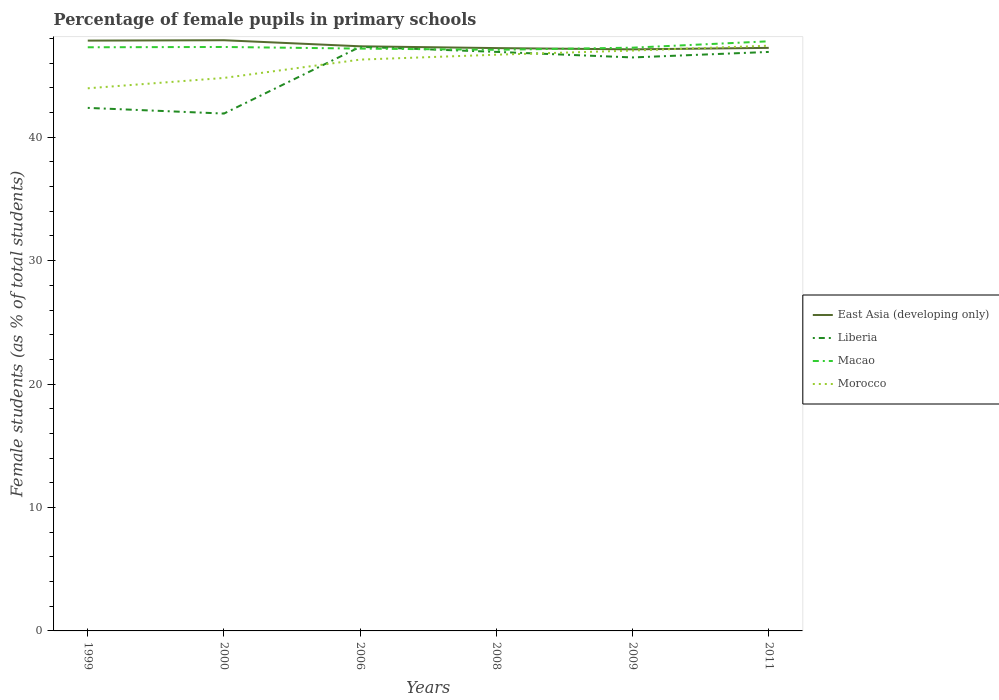Does the line corresponding to East Asia (developing only) intersect with the line corresponding to Morocco?
Your answer should be compact. Yes. Across all years, what is the maximum percentage of female pupils in primary schools in Morocco?
Your response must be concise. 43.97. What is the total percentage of female pupils in primary schools in Liberia in the graph?
Give a very brief answer. -5. What is the difference between the highest and the second highest percentage of female pupils in primary schools in Liberia?
Make the answer very short. 5.41. Is the percentage of female pupils in primary schools in Morocco strictly greater than the percentage of female pupils in primary schools in East Asia (developing only) over the years?
Give a very brief answer. No. How many years are there in the graph?
Provide a short and direct response. 6. How many legend labels are there?
Ensure brevity in your answer.  4. How are the legend labels stacked?
Give a very brief answer. Vertical. What is the title of the graph?
Provide a short and direct response. Percentage of female pupils in primary schools. What is the label or title of the Y-axis?
Provide a short and direct response. Female students (as % of total students). What is the Female students (as % of total students) of East Asia (developing only) in 1999?
Give a very brief answer. 47.83. What is the Female students (as % of total students) of Liberia in 1999?
Provide a short and direct response. 42.38. What is the Female students (as % of total students) in Macao in 1999?
Your response must be concise. 47.29. What is the Female students (as % of total students) of Morocco in 1999?
Provide a short and direct response. 43.97. What is the Female students (as % of total students) in East Asia (developing only) in 2000?
Ensure brevity in your answer.  47.86. What is the Female students (as % of total students) in Liberia in 2000?
Ensure brevity in your answer.  41.92. What is the Female students (as % of total students) of Macao in 2000?
Provide a succinct answer. 47.31. What is the Female students (as % of total students) of Morocco in 2000?
Your answer should be very brief. 44.81. What is the Female students (as % of total students) of East Asia (developing only) in 2006?
Your answer should be compact. 47.37. What is the Female students (as % of total students) in Liberia in 2006?
Provide a short and direct response. 47.33. What is the Female students (as % of total students) in Macao in 2006?
Your response must be concise. 47.18. What is the Female students (as % of total students) in Morocco in 2006?
Your answer should be very brief. 46.29. What is the Female students (as % of total students) of East Asia (developing only) in 2008?
Make the answer very short. 47.22. What is the Female students (as % of total students) of Liberia in 2008?
Offer a very short reply. 46.92. What is the Female students (as % of total students) of Macao in 2008?
Offer a very short reply. 47.09. What is the Female students (as % of total students) in Morocco in 2008?
Provide a succinct answer. 46.69. What is the Female students (as % of total students) in East Asia (developing only) in 2009?
Offer a terse response. 47.12. What is the Female students (as % of total students) of Liberia in 2009?
Make the answer very short. 46.47. What is the Female students (as % of total students) of Macao in 2009?
Give a very brief answer. 47.26. What is the Female students (as % of total students) in Morocco in 2009?
Your answer should be very brief. 47.03. What is the Female students (as % of total students) in East Asia (developing only) in 2011?
Make the answer very short. 47.24. What is the Female students (as % of total students) of Liberia in 2011?
Give a very brief answer. 46.91. What is the Female students (as % of total students) in Macao in 2011?
Keep it short and to the point. 47.77. What is the Female students (as % of total students) of Morocco in 2011?
Your response must be concise. 47.42. Across all years, what is the maximum Female students (as % of total students) in East Asia (developing only)?
Ensure brevity in your answer.  47.86. Across all years, what is the maximum Female students (as % of total students) in Liberia?
Offer a very short reply. 47.33. Across all years, what is the maximum Female students (as % of total students) of Macao?
Keep it short and to the point. 47.77. Across all years, what is the maximum Female students (as % of total students) in Morocco?
Provide a short and direct response. 47.42. Across all years, what is the minimum Female students (as % of total students) in East Asia (developing only)?
Ensure brevity in your answer.  47.12. Across all years, what is the minimum Female students (as % of total students) of Liberia?
Keep it short and to the point. 41.92. Across all years, what is the minimum Female students (as % of total students) in Macao?
Offer a terse response. 47.09. Across all years, what is the minimum Female students (as % of total students) of Morocco?
Give a very brief answer. 43.97. What is the total Female students (as % of total students) of East Asia (developing only) in the graph?
Provide a short and direct response. 284.65. What is the total Female students (as % of total students) of Liberia in the graph?
Make the answer very short. 271.92. What is the total Female students (as % of total students) of Macao in the graph?
Offer a very short reply. 283.91. What is the total Female students (as % of total students) of Morocco in the graph?
Your answer should be compact. 276.2. What is the difference between the Female students (as % of total students) of East Asia (developing only) in 1999 and that in 2000?
Make the answer very short. -0.03. What is the difference between the Female students (as % of total students) of Liberia in 1999 and that in 2000?
Make the answer very short. 0.46. What is the difference between the Female students (as % of total students) of Macao in 1999 and that in 2000?
Offer a terse response. -0.02. What is the difference between the Female students (as % of total students) in Morocco in 1999 and that in 2000?
Keep it short and to the point. -0.84. What is the difference between the Female students (as % of total students) of East Asia (developing only) in 1999 and that in 2006?
Make the answer very short. 0.46. What is the difference between the Female students (as % of total students) in Liberia in 1999 and that in 2006?
Give a very brief answer. -4.95. What is the difference between the Female students (as % of total students) of Macao in 1999 and that in 2006?
Provide a short and direct response. 0.11. What is the difference between the Female students (as % of total students) in Morocco in 1999 and that in 2006?
Ensure brevity in your answer.  -2.32. What is the difference between the Female students (as % of total students) of East Asia (developing only) in 1999 and that in 2008?
Make the answer very short. 0.61. What is the difference between the Female students (as % of total students) of Liberia in 1999 and that in 2008?
Give a very brief answer. -4.54. What is the difference between the Female students (as % of total students) of Macao in 1999 and that in 2008?
Offer a very short reply. 0.2. What is the difference between the Female students (as % of total students) of Morocco in 1999 and that in 2008?
Provide a succinct answer. -2.72. What is the difference between the Female students (as % of total students) of East Asia (developing only) in 1999 and that in 2009?
Give a very brief answer. 0.71. What is the difference between the Female students (as % of total students) in Liberia in 1999 and that in 2009?
Keep it short and to the point. -4.09. What is the difference between the Female students (as % of total students) of Macao in 1999 and that in 2009?
Make the answer very short. 0.03. What is the difference between the Female students (as % of total students) of Morocco in 1999 and that in 2009?
Keep it short and to the point. -3.06. What is the difference between the Female students (as % of total students) in East Asia (developing only) in 1999 and that in 2011?
Your answer should be compact. 0.59. What is the difference between the Female students (as % of total students) in Liberia in 1999 and that in 2011?
Your response must be concise. -4.53. What is the difference between the Female students (as % of total students) in Macao in 1999 and that in 2011?
Your answer should be very brief. -0.48. What is the difference between the Female students (as % of total students) of Morocco in 1999 and that in 2011?
Your response must be concise. -3.45. What is the difference between the Female students (as % of total students) of East Asia (developing only) in 2000 and that in 2006?
Offer a very short reply. 0.49. What is the difference between the Female students (as % of total students) of Liberia in 2000 and that in 2006?
Ensure brevity in your answer.  -5.41. What is the difference between the Female students (as % of total students) of Macao in 2000 and that in 2006?
Offer a terse response. 0.13. What is the difference between the Female students (as % of total students) in Morocco in 2000 and that in 2006?
Give a very brief answer. -1.49. What is the difference between the Female students (as % of total students) of East Asia (developing only) in 2000 and that in 2008?
Offer a very short reply. 0.64. What is the difference between the Female students (as % of total students) in Liberia in 2000 and that in 2008?
Keep it short and to the point. -5. What is the difference between the Female students (as % of total students) in Macao in 2000 and that in 2008?
Your response must be concise. 0.23. What is the difference between the Female students (as % of total students) in Morocco in 2000 and that in 2008?
Offer a very short reply. -1.88. What is the difference between the Female students (as % of total students) in East Asia (developing only) in 2000 and that in 2009?
Your response must be concise. 0.74. What is the difference between the Female students (as % of total students) of Liberia in 2000 and that in 2009?
Make the answer very short. -4.55. What is the difference between the Female students (as % of total students) in Macao in 2000 and that in 2009?
Provide a short and direct response. 0.06. What is the difference between the Female students (as % of total students) of Morocco in 2000 and that in 2009?
Your answer should be compact. -2.22. What is the difference between the Female students (as % of total students) of East Asia (developing only) in 2000 and that in 2011?
Your answer should be compact. 0.62. What is the difference between the Female students (as % of total students) in Liberia in 2000 and that in 2011?
Your answer should be compact. -4.99. What is the difference between the Female students (as % of total students) of Macao in 2000 and that in 2011?
Provide a succinct answer. -0.46. What is the difference between the Female students (as % of total students) in Morocco in 2000 and that in 2011?
Your answer should be very brief. -2.61. What is the difference between the Female students (as % of total students) in East Asia (developing only) in 2006 and that in 2008?
Your answer should be very brief. 0.14. What is the difference between the Female students (as % of total students) in Liberia in 2006 and that in 2008?
Your response must be concise. 0.41. What is the difference between the Female students (as % of total students) in Macao in 2006 and that in 2008?
Offer a terse response. 0.1. What is the difference between the Female students (as % of total students) of Morocco in 2006 and that in 2008?
Your answer should be very brief. -0.4. What is the difference between the Female students (as % of total students) of East Asia (developing only) in 2006 and that in 2009?
Provide a short and direct response. 0.25. What is the difference between the Female students (as % of total students) of Liberia in 2006 and that in 2009?
Provide a succinct answer. 0.86. What is the difference between the Female students (as % of total students) in Macao in 2006 and that in 2009?
Your answer should be compact. -0.07. What is the difference between the Female students (as % of total students) of Morocco in 2006 and that in 2009?
Your answer should be compact. -0.73. What is the difference between the Female students (as % of total students) of East Asia (developing only) in 2006 and that in 2011?
Your response must be concise. 0.13. What is the difference between the Female students (as % of total students) of Liberia in 2006 and that in 2011?
Make the answer very short. 0.41. What is the difference between the Female students (as % of total students) in Macao in 2006 and that in 2011?
Keep it short and to the point. -0.59. What is the difference between the Female students (as % of total students) in Morocco in 2006 and that in 2011?
Your answer should be compact. -1.13. What is the difference between the Female students (as % of total students) of East Asia (developing only) in 2008 and that in 2009?
Your answer should be very brief. 0.1. What is the difference between the Female students (as % of total students) of Liberia in 2008 and that in 2009?
Provide a succinct answer. 0.45. What is the difference between the Female students (as % of total students) of Macao in 2008 and that in 2009?
Give a very brief answer. -0.17. What is the difference between the Female students (as % of total students) of Morocco in 2008 and that in 2009?
Provide a short and direct response. -0.34. What is the difference between the Female students (as % of total students) in East Asia (developing only) in 2008 and that in 2011?
Your answer should be very brief. -0.02. What is the difference between the Female students (as % of total students) in Liberia in 2008 and that in 2011?
Offer a terse response. 0. What is the difference between the Female students (as % of total students) in Macao in 2008 and that in 2011?
Your response must be concise. -0.69. What is the difference between the Female students (as % of total students) in Morocco in 2008 and that in 2011?
Ensure brevity in your answer.  -0.73. What is the difference between the Female students (as % of total students) of East Asia (developing only) in 2009 and that in 2011?
Make the answer very short. -0.12. What is the difference between the Female students (as % of total students) in Liberia in 2009 and that in 2011?
Provide a short and direct response. -0.45. What is the difference between the Female students (as % of total students) in Macao in 2009 and that in 2011?
Your response must be concise. -0.52. What is the difference between the Female students (as % of total students) in Morocco in 2009 and that in 2011?
Provide a succinct answer. -0.39. What is the difference between the Female students (as % of total students) of East Asia (developing only) in 1999 and the Female students (as % of total students) of Liberia in 2000?
Offer a very short reply. 5.91. What is the difference between the Female students (as % of total students) of East Asia (developing only) in 1999 and the Female students (as % of total students) of Macao in 2000?
Offer a very short reply. 0.52. What is the difference between the Female students (as % of total students) in East Asia (developing only) in 1999 and the Female students (as % of total students) in Morocco in 2000?
Your response must be concise. 3.02. What is the difference between the Female students (as % of total students) of Liberia in 1999 and the Female students (as % of total students) of Macao in 2000?
Provide a succinct answer. -4.94. What is the difference between the Female students (as % of total students) in Liberia in 1999 and the Female students (as % of total students) in Morocco in 2000?
Ensure brevity in your answer.  -2.43. What is the difference between the Female students (as % of total students) in Macao in 1999 and the Female students (as % of total students) in Morocco in 2000?
Keep it short and to the point. 2.48. What is the difference between the Female students (as % of total students) of East Asia (developing only) in 1999 and the Female students (as % of total students) of Liberia in 2006?
Offer a very short reply. 0.51. What is the difference between the Female students (as % of total students) of East Asia (developing only) in 1999 and the Female students (as % of total students) of Macao in 2006?
Offer a terse response. 0.65. What is the difference between the Female students (as % of total students) of East Asia (developing only) in 1999 and the Female students (as % of total students) of Morocco in 2006?
Provide a succinct answer. 1.54. What is the difference between the Female students (as % of total students) in Liberia in 1999 and the Female students (as % of total students) in Macao in 2006?
Provide a succinct answer. -4.8. What is the difference between the Female students (as % of total students) in Liberia in 1999 and the Female students (as % of total students) in Morocco in 2006?
Your answer should be compact. -3.91. What is the difference between the Female students (as % of total students) of Macao in 1999 and the Female students (as % of total students) of Morocco in 2006?
Your answer should be very brief. 1. What is the difference between the Female students (as % of total students) of East Asia (developing only) in 1999 and the Female students (as % of total students) of Liberia in 2008?
Ensure brevity in your answer.  0.91. What is the difference between the Female students (as % of total students) in East Asia (developing only) in 1999 and the Female students (as % of total students) in Macao in 2008?
Keep it short and to the point. 0.75. What is the difference between the Female students (as % of total students) in East Asia (developing only) in 1999 and the Female students (as % of total students) in Morocco in 2008?
Your answer should be compact. 1.14. What is the difference between the Female students (as % of total students) in Liberia in 1999 and the Female students (as % of total students) in Macao in 2008?
Give a very brief answer. -4.71. What is the difference between the Female students (as % of total students) of Liberia in 1999 and the Female students (as % of total students) of Morocco in 2008?
Offer a terse response. -4.31. What is the difference between the Female students (as % of total students) of Macao in 1999 and the Female students (as % of total students) of Morocco in 2008?
Give a very brief answer. 0.6. What is the difference between the Female students (as % of total students) of East Asia (developing only) in 1999 and the Female students (as % of total students) of Liberia in 2009?
Provide a succinct answer. 1.36. What is the difference between the Female students (as % of total students) in East Asia (developing only) in 1999 and the Female students (as % of total students) in Macao in 2009?
Offer a terse response. 0.57. What is the difference between the Female students (as % of total students) in East Asia (developing only) in 1999 and the Female students (as % of total students) in Morocco in 2009?
Your answer should be compact. 0.81. What is the difference between the Female students (as % of total students) in Liberia in 1999 and the Female students (as % of total students) in Macao in 2009?
Provide a succinct answer. -4.88. What is the difference between the Female students (as % of total students) of Liberia in 1999 and the Female students (as % of total students) of Morocco in 2009?
Ensure brevity in your answer.  -4.65. What is the difference between the Female students (as % of total students) in Macao in 1999 and the Female students (as % of total students) in Morocco in 2009?
Keep it short and to the point. 0.27. What is the difference between the Female students (as % of total students) of East Asia (developing only) in 1999 and the Female students (as % of total students) of Liberia in 2011?
Your response must be concise. 0.92. What is the difference between the Female students (as % of total students) in East Asia (developing only) in 1999 and the Female students (as % of total students) in Macao in 2011?
Offer a very short reply. 0.06. What is the difference between the Female students (as % of total students) in East Asia (developing only) in 1999 and the Female students (as % of total students) in Morocco in 2011?
Provide a succinct answer. 0.41. What is the difference between the Female students (as % of total students) of Liberia in 1999 and the Female students (as % of total students) of Macao in 2011?
Ensure brevity in your answer.  -5.39. What is the difference between the Female students (as % of total students) of Liberia in 1999 and the Female students (as % of total students) of Morocco in 2011?
Provide a short and direct response. -5.04. What is the difference between the Female students (as % of total students) of Macao in 1999 and the Female students (as % of total students) of Morocco in 2011?
Offer a very short reply. -0.13. What is the difference between the Female students (as % of total students) of East Asia (developing only) in 2000 and the Female students (as % of total students) of Liberia in 2006?
Provide a short and direct response. 0.53. What is the difference between the Female students (as % of total students) of East Asia (developing only) in 2000 and the Female students (as % of total students) of Macao in 2006?
Offer a terse response. 0.68. What is the difference between the Female students (as % of total students) of East Asia (developing only) in 2000 and the Female students (as % of total students) of Morocco in 2006?
Provide a succinct answer. 1.57. What is the difference between the Female students (as % of total students) of Liberia in 2000 and the Female students (as % of total students) of Macao in 2006?
Make the answer very short. -5.26. What is the difference between the Female students (as % of total students) of Liberia in 2000 and the Female students (as % of total students) of Morocco in 2006?
Provide a succinct answer. -4.37. What is the difference between the Female students (as % of total students) of Macao in 2000 and the Female students (as % of total students) of Morocco in 2006?
Give a very brief answer. 1.02. What is the difference between the Female students (as % of total students) of East Asia (developing only) in 2000 and the Female students (as % of total students) of Liberia in 2008?
Your answer should be very brief. 0.94. What is the difference between the Female students (as % of total students) in East Asia (developing only) in 2000 and the Female students (as % of total students) in Macao in 2008?
Provide a succinct answer. 0.77. What is the difference between the Female students (as % of total students) in East Asia (developing only) in 2000 and the Female students (as % of total students) in Morocco in 2008?
Keep it short and to the point. 1.17. What is the difference between the Female students (as % of total students) of Liberia in 2000 and the Female students (as % of total students) of Macao in 2008?
Keep it short and to the point. -5.17. What is the difference between the Female students (as % of total students) of Liberia in 2000 and the Female students (as % of total students) of Morocco in 2008?
Your answer should be compact. -4.77. What is the difference between the Female students (as % of total students) of Macao in 2000 and the Female students (as % of total students) of Morocco in 2008?
Ensure brevity in your answer.  0.63. What is the difference between the Female students (as % of total students) in East Asia (developing only) in 2000 and the Female students (as % of total students) in Liberia in 2009?
Your answer should be compact. 1.39. What is the difference between the Female students (as % of total students) in East Asia (developing only) in 2000 and the Female students (as % of total students) in Macao in 2009?
Your answer should be compact. 0.6. What is the difference between the Female students (as % of total students) in East Asia (developing only) in 2000 and the Female students (as % of total students) in Morocco in 2009?
Your answer should be very brief. 0.84. What is the difference between the Female students (as % of total students) in Liberia in 2000 and the Female students (as % of total students) in Macao in 2009?
Your answer should be very brief. -5.34. What is the difference between the Female students (as % of total students) in Liberia in 2000 and the Female students (as % of total students) in Morocco in 2009?
Offer a very short reply. -5.11. What is the difference between the Female students (as % of total students) of Macao in 2000 and the Female students (as % of total students) of Morocco in 2009?
Keep it short and to the point. 0.29. What is the difference between the Female students (as % of total students) in East Asia (developing only) in 2000 and the Female students (as % of total students) in Liberia in 2011?
Ensure brevity in your answer.  0.95. What is the difference between the Female students (as % of total students) in East Asia (developing only) in 2000 and the Female students (as % of total students) in Macao in 2011?
Offer a very short reply. 0.09. What is the difference between the Female students (as % of total students) of East Asia (developing only) in 2000 and the Female students (as % of total students) of Morocco in 2011?
Your answer should be compact. 0.44. What is the difference between the Female students (as % of total students) in Liberia in 2000 and the Female students (as % of total students) in Macao in 2011?
Provide a short and direct response. -5.85. What is the difference between the Female students (as % of total students) of Liberia in 2000 and the Female students (as % of total students) of Morocco in 2011?
Offer a very short reply. -5.5. What is the difference between the Female students (as % of total students) in Macao in 2000 and the Female students (as % of total students) in Morocco in 2011?
Give a very brief answer. -0.1. What is the difference between the Female students (as % of total students) in East Asia (developing only) in 2006 and the Female students (as % of total students) in Liberia in 2008?
Make the answer very short. 0.45. What is the difference between the Female students (as % of total students) of East Asia (developing only) in 2006 and the Female students (as % of total students) of Macao in 2008?
Make the answer very short. 0.28. What is the difference between the Female students (as % of total students) of East Asia (developing only) in 2006 and the Female students (as % of total students) of Morocco in 2008?
Your answer should be very brief. 0.68. What is the difference between the Female students (as % of total students) of Liberia in 2006 and the Female students (as % of total students) of Macao in 2008?
Your answer should be very brief. 0.24. What is the difference between the Female students (as % of total students) of Liberia in 2006 and the Female students (as % of total students) of Morocco in 2008?
Your response must be concise. 0.64. What is the difference between the Female students (as % of total students) in Macao in 2006 and the Female students (as % of total students) in Morocco in 2008?
Provide a short and direct response. 0.49. What is the difference between the Female students (as % of total students) of East Asia (developing only) in 2006 and the Female students (as % of total students) of Liberia in 2009?
Your answer should be very brief. 0.9. What is the difference between the Female students (as % of total students) in East Asia (developing only) in 2006 and the Female students (as % of total students) in Macao in 2009?
Your response must be concise. 0.11. What is the difference between the Female students (as % of total students) in East Asia (developing only) in 2006 and the Female students (as % of total students) in Morocco in 2009?
Give a very brief answer. 0.34. What is the difference between the Female students (as % of total students) in Liberia in 2006 and the Female students (as % of total students) in Macao in 2009?
Provide a short and direct response. 0.07. What is the difference between the Female students (as % of total students) in Liberia in 2006 and the Female students (as % of total students) in Morocco in 2009?
Your answer should be compact. 0.3. What is the difference between the Female students (as % of total students) in Macao in 2006 and the Female students (as % of total students) in Morocco in 2009?
Keep it short and to the point. 0.16. What is the difference between the Female students (as % of total students) in East Asia (developing only) in 2006 and the Female students (as % of total students) in Liberia in 2011?
Give a very brief answer. 0.46. What is the difference between the Female students (as % of total students) in East Asia (developing only) in 2006 and the Female students (as % of total students) in Macao in 2011?
Give a very brief answer. -0.4. What is the difference between the Female students (as % of total students) in East Asia (developing only) in 2006 and the Female students (as % of total students) in Morocco in 2011?
Your response must be concise. -0.05. What is the difference between the Female students (as % of total students) of Liberia in 2006 and the Female students (as % of total students) of Macao in 2011?
Provide a succinct answer. -0.45. What is the difference between the Female students (as % of total students) of Liberia in 2006 and the Female students (as % of total students) of Morocco in 2011?
Offer a very short reply. -0.09. What is the difference between the Female students (as % of total students) in Macao in 2006 and the Female students (as % of total students) in Morocco in 2011?
Make the answer very short. -0.24. What is the difference between the Female students (as % of total students) of East Asia (developing only) in 2008 and the Female students (as % of total students) of Liberia in 2009?
Provide a short and direct response. 0.76. What is the difference between the Female students (as % of total students) of East Asia (developing only) in 2008 and the Female students (as % of total students) of Macao in 2009?
Offer a very short reply. -0.03. What is the difference between the Female students (as % of total students) of East Asia (developing only) in 2008 and the Female students (as % of total students) of Morocco in 2009?
Provide a short and direct response. 0.2. What is the difference between the Female students (as % of total students) in Liberia in 2008 and the Female students (as % of total students) in Macao in 2009?
Provide a succinct answer. -0.34. What is the difference between the Female students (as % of total students) in Liberia in 2008 and the Female students (as % of total students) in Morocco in 2009?
Offer a very short reply. -0.11. What is the difference between the Female students (as % of total students) in Macao in 2008 and the Female students (as % of total students) in Morocco in 2009?
Your answer should be very brief. 0.06. What is the difference between the Female students (as % of total students) of East Asia (developing only) in 2008 and the Female students (as % of total students) of Liberia in 2011?
Make the answer very short. 0.31. What is the difference between the Female students (as % of total students) in East Asia (developing only) in 2008 and the Female students (as % of total students) in Macao in 2011?
Give a very brief answer. -0.55. What is the difference between the Female students (as % of total students) in East Asia (developing only) in 2008 and the Female students (as % of total students) in Morocco in 2011?
Keep it short and to the point. -0.2. What is the difference between the Female students (as % of total students) of Liberia in 2008 and the Female students (as % of total students) of Macao in 2011?
Your answer should be very brief. -0.86. What is the difference between the Female students (as % of total students) in Liberia in 2008 and the Female students (as % of total students) in Morocco in 2011?
Make the answer very short. -0.5. What is the difference between the Female students (as % of total students) in Macao in 2008 and the Female students (as % of total students) in Morocco in 2011?
Ensure brevity in your answer.  -0.33. What is the difference between the Female students (as % of total students) in East Asia (developing only) in 2009 and the Female students (as % of total students) in Liberia in 2011?
Offer a very short reply. 0.21. What is the difference between the Female students (as % of total students) of East Asia (developing only) in 2009 and the Female students (as % of total students) of Macao in 2011?
Offer a terse response. -0.65. What is the difference between the Female students (as % of total students) in East Asia (developing only) in 2009 and the Female students (as % of total students) in Morocco in 2011?
Keep it short and to the point. -0.3. What is the difference between the Female students (as % of total students) of Liberia in 2009 and the Female students (as % of total students) of Macao in 2011?
Your response must be concise. -1.31. What is the difference between the Female students (as % of total students) of Liberia in 2009 and the Female students (as % of total students) of Morocco in 2011?
Offer a very short reply. -0.95. What is the difference between the Female students (as % of total students) of Macao in 2009 and the Female students (as % of total students) of Morocco in 2011?
Offer a very short reply. -0.16. What is the average Female students (as % of total students) in East Asia (developing only) per year?
Ensure brevity in your answer.  47.44. What is the average Female students (as % of total students) of Liberia per year?
Ensure brevity in your answer.  45.32. What is the average Female students (as % of total students) in Macao per year?
Your response must be concise. 47.32. What is the average Female students (as % of total students) in Morocco per year?
Offer a very short reply. 46.03. In the year 1999, what is the difference between the Female students (as % of total students) in East Asia (developing only) and Female students (as % of total students) in Liberia?
Offer a terse response. 5.45. In the year 1999, what is the difference between the Female students (as % of total students) in East Asia (developing only) and Female students (as % of total students) in Macao?
Offer a very short reply. 0.54. In the year 1999, what is the difference between the Female students (as % of total students) of East Asia (developing only) and Female students (as % of total students) of Morocco?
Your response must be concise. 3.86. In the year 1999, what is the difference between the Female students (as % of total students) of Liberia and Female students (as % of total students) of Macao?
Make the answer very short. -4.91. In the year 1999, what is the difference between the Female students (as % of total students) in Liberia and Female students (as % of total students) in Morocco?
Your answer should be very brief. -1.59. In the year 1999, what is the difference between the Female students (as % of total students) in Macao and Female students (as % of total students) in Morocco?
Keep it short and to the point. 3.32. In the year 2000, what is the difference between the Female students (as % of total students) of East Asia (developing only) and Female students (as % of total students) of Liberia?
Your answer should be compact. 5.94. In the year 2000, what is the difference between the Female students (as % of total students) in East Asia (developing only) and Female students (as % of total students) in Macao?
Keep it short and to the point. 0.55. In the year 2000, what is the difference between the Female students (as % of total students) in East Asia (developing only) and Female students (as % of total students) in Morocco?
Offer a very short reply. 3.05. In the year 2000, what is the difference between the Female students (as % of total students) of Liberia and Female students (as % of total students) of Macao?
Keep it short and to the point. -5.4. In the year 2000, what is the difference between the Female students (as % of total students) in Liberia and Female students (as % of total students) in Morocco?
Keep it short and to the point. -2.89. In the year 2000, what is the difference between the Female students (as % of total students) in Macao and Female students (as % of total students) in Morocco?
Offer a very short reply. 2.51. In the year 2006, what is the difference between the Female students (as % of total students) in East Asia (developing only) and Female students (as % of total students) in Liberia?
Make the answer very short. 0.04. In the year 2006, what is the difference between the Female students (as % of total students) in East Asia (developing only) and Female students (as % of total students) in Macao?
Provide a short and direct response. 0.19. In the year 2006, what is the difference between the Female students (as % of total students) in East Asia (developing only) and Female students (as % of total students) in Morocco?
Make the answer very short. 1.08. In the year 2006, what is the difference between the Female students (as % of total students) in Liberia and Female students (as % of total students) in Macao?
Your answer should be compact. 0.14. In the year 2006, what is the difference between the Female students (as % of total students) in Liberia and Female students (as % of total students) in Morocco?
Offer a very short reply. 1.03. In the year 2006, what is the difference between the Female students (as % of total students) of Macao and Female students (as % of total students) of Morocco?
Ensure brevity in your answer.  0.89. In the year 2008, what is the difference between the Female students (as % of total students) of East Asia (developing only) and Female students (as % of total students) of Liberia?
Offer a terse response. 0.31. In the year 2008, what is the difference between the Female students (as % of total students) of East Asia (developing only) and Female students (as % of total students) of Macao?
Offer a terse response. 0.14. In the year 2008, what is the difference between the Female students (as % of total students) in East Asia (developing only) and Female students (as % of total students) in Morocco?
Provide a short and direct response. 0.54. In the year 2008, what is the difference between the Female students (as % of total students) in Liberia and Female students (as % of total students) in Macao?
Give a very brief answer. -0.17. In the year 2008, what is the difference between the Female students (as % of total students) of Liberia and Female students (as % of total students) of Morocco?
Make the answer very short. 0.23. In the year 2008, what is the difference between the Female students (as % of total students) of Macao and Female students (as % of total students) of Morocco?
Make the answer very short. 0.4. In the year 2009, what is the difference between the Female students (as % of total students) of East Asia (developing only) and Female students (as % of total students) of Liberia?
Offer a terse response. 0.66. In the year 2009, what is the difference between the Female students (as % of total students) of East Asia (developing only) and Female students (as % of total students) of Macao?
Your response must be concise. -0.14. In the year 2009, what is the difference between the Female students (as % of total students) of East Asia (developing only) and Female students (as % of total students) of Morocco?
Provide a short and direct response. 0.1. In the year 2009, what is the difference between the Female students (as % of total students) of Liberia and Female students (as % of total students) of Macao?
Keep it short and to the point. -0.79. In the year 2009, what is the difference between the Female students (as % of total students) in Liberia and Female students (as % of total students) in Morocco?
Offer a very short reply. -0.56. In the year 2009, what is the difference between the Female students (as % of total students) in Macao and Female students (as % of total students) in Morocco?
Your answer should be compact. 0.23. In the year 2011, what is the difference between the Female students (as % of total students) in East Asia (developing only) and Female students (as % of total students) in Liberia?
Make the answer very short. 0.33. In the year 2011, what is the difference between the Female students (as % of total students) in East Asia (developing only) and Female students (as % of total students) in Macao?
Your response must be concise. -0.53. In the year 2011, what is the difference between the Female students (as % of total students) of East Asia (developing only) and Female students (as % of total students) of Morocco?
Ensure brevity in your answer.  -0.18. In the year 2011, what is the difference between the Female students (as % of total students) in Liberia and Female students (as % of total students) in Macao?
Ensure brevity in your answer.  -0.86. In the year 2011, what is the difference between the Female students (as % of total students) in Liberia and Female students (as % of total students) in Morocco?
Make the answer very short. -0.51. In the year 2011, what is the difference between the Female students (as % of total students) of Macao and Female students (as % of total students) of Morocco?
Provide a short and direct response. 0.35. What is the ratio of the Female students (as % of total students) in East Asia (developing only) in 1999 to that in 2000?
Your answer should be compact. 1. What is the ratio of the Female students (as % of total students) in Liberia in 1999 to that in 2000?
Make the answer very short. 1.01. What is the ratio of the Female students (as % of total students) of Morocco in 1999 to that in 2000?
Provide a succinct answer. 0.98. What is the ratio of the Female students (as % of total students) of East Asia (developing only) in 1999 to that in 2006?
Your answer should be very brief. 1.01. What is the ratio of the Female students (as % of total students) in Liberia in 1999 to that in 2006?
Your answer should be compact. 0.9. What is the ratio of the Female students (as % of total students) of Morocco in 1999 to that in 2006?
Your response must be concise. 0.95. What is the ratio of the Female students (as % of total students) in East Asia (developing only) in 1999 to that in 2008?
Provide a succinct answer. 1.01. What is the ratio of the Female students (as % of total students) of Liberia in 1999 to that in 2008?
Provide a short and direct response. 0.9. What is the ratio of the Female students (as % of total students) in Macao in 1999 to that in 2008?
Give a very brief answer. 1. What is the ratio of the Female students (as % of total students) in Morocco in 1999 to that in 2008?
Your response must be concise. 0.94. What is the ratio of the Female students (as % of total students) of Liberia in 1999 to that in 2009?
Make the answer very short. 0.91. What is the ratio of the Female students (as % of total students) in Macao in 1999 to that in 2009?
Provide a succinct answer. 1. What is the ratio of the Female students (as % of total students) of Morocco in 1999 to that in 2009?
Offer a terse response. 0.94. What is the ratio of the Female students (as % of total students) of East Asia (developing only) in 1999 to that in 2011?
Provide a short and direct response. 1.01. What is the ratio of the Female students (as % of total students) in Liberia in 1999 to that in 2011?
Keep it short and to the point. 0.9. What is the ratio of the Female students (as % of total students) in Morocco in 1999 to that in 2011?
Your answer should be very brief. 0.93. What is the ratio of the Female students (as % of total students) of East Asia (developing only) in 2000 to that in 2006?
Your response must be concise. 1.01. What is the ratio of the Female students (as % of total students) of Liberia in 2000 to that in 2006?
Your answer should be very brief. 0.89. What is the ratio of the Female students (as % of total students) in Morocco in 2000 to that in 2006?
Keep it short and to the point. 0.97. What is the ratio of the Female students (as % of total students) in East Asia (developing only) in 2000 to that in 2008?
Provide a short and direct response. 1.01. What is the ratio of the Female students (as % of total students) in Liberia in 2000 to that in 2008?
Your response must be concise. 0.89. What is the ratio of the Female students (as % of total students) of Macao in 2000 to that in 2008?
Ensure brevity in your answer.  1. What is the ratio of the Female students (as % of total students) of Morocco in 2000 to that in 2008?
Make the answer very short. 0.96. What is the ratio of the Female students (as % of total students) in East Asia (developing only) in 2000 to that in 2009?
Your answer should be very brief. 1.02. What is the ratio of the Female students (as % of total students) of Liberia in 2000 to that in 2009?
Provide a succinct answer. 0.9. What is the ratio of the Female students (as % of total students) of Morocco in 2000 to that in 2009?
Give a very brief answer. 0.95. What is the ratio of the Female students (as % of total students) in East Asia (developing only) in 2000 to that in 2011?
Keep it short and to the point. 1.01. What is the ratio of the Female students (as % of total students) in Liberia in 2000 to that in 2011?
Provide a succinct answer. 0.89. What is the ratio of the Female students (as % of total students) of Morocco in 2000 to that in 2011?
Offer a terse response. 0.94. What is the ratio of the Female students (as % of total students) in Liberia in 2006 to that in 2008?
Provide a succinct answer. 1.01. What is the ratio of the Female students (as % of total students) of Macao in 2006 to that in 2008?
Ensure brevity in your answer.  1. What is the ratio of the Female students (as % of total students) of East Asia (developing only) in 2006 to that in 2009?
Offer a terse response. 1.01. What is the ratio of the Female students (as % of total students) in Liberia in 2006 to that in 2009?
Provide a succinct answer. 1.02. What is the ratio of the Female students (as % of total students) of Macao in 2006 to that in 2009?
Provide a short and direct response. 1. What is the ratio of the Female students (as % of total students) in Morocco in 2006 to that in 2009?
Ensure brevity in your answer.  0.98. What is the ratio of the Female students (as % of total students) of East Asia (developing only) in 2006 to that in 2011?
Your answer should be very brief. 1. What is the ratio of the Female students (as % of total students) of Liberia in 2006 to that in 2011?
Provide a short and direct response. 1.01. What is the ratio of the Female students (as % of total students) in Macao in 2006 to that in 2011?
Offer a very short reply. 0.99. What is the ratio of the Female students (as % of total students) of Morocco in 2006 to that in 2011?
Offer a terse response. 0.98. What is the ratio of the Female students (as % of total students) in East Asia (developing only) in 2008 to that in 2009?
Keep it short and to the point. 1. What is the ratio of the Female students (as % of total students) of Liberia in 2008 to that in 2009?
Keep it short and to the point. 1.01. What is the ratio of the Female students (as % of total students) in Macao in 2008 to that in 2009?
Ensure brevity in your answer.  1. What is the ratio of the Female students (as % of total students) of Morocco in 2008 to that in 2009?
Keep it short and to the point. 0.99. What is the ratio of the Female students (as % of total students) of Liberia in 2008 to that in 2011?
Provide a short and direct response. 1. What is the ratio of the Female students (as % of total students) of Macao in 2008 to that in 2011?
Your response must be concise. 0.99. What is the ratio of the Female students (as % of total students) in Morocco in 2008 to that in 2011?
Provide a short and direct response. 0.98. What is the ratio of the Female students (as % of total students) in East Asia (developing only) in 2009 to that in 2011?
Your response must be concise. 1. What is the ratio of the Female students (as % of total students) in Liberia in 2009 to that in 2011?
Your answer should be very brief. 0.99. What is the ratio of the Female students (as % of total students) in Macao in 2009 to that in 2011?
Provide a short and direct response. 0.99. What is the difference between the highest and the second highest Female students (as % of total students) in East Asia (developing only)?
Offer a very short reply. 0.03. What is the difference between the highest and the second highest Female students (as % of total students) of Liberia?
Ensure brevity in your answer.  0.41. What is the difference between the highest and the second highest Female students (as % of total students) in Macao?
Provide a short and direct response. 0.46. What is the difference between the highest and the second highest Female students (as % of total students) in Morocco?
Your response must be concise. 0.39. What is the difference between the highest and the lowest Female students (as % of total students) of East Asia (developing only)?
Your response must be concise. 0.74. What is the difference between the highest and the lowest Female students (as % of total students) in Liberia?
Provide a short and direct response. 5.41. What is the difference between the highest and the lowest Female students (as % of total students) of Macao?
Keep it short and to the point. 0.69. What is the difference between the highest and the lowest Female students (as % of total students) in Morocco?
Give a very brief answer. 3.45. 